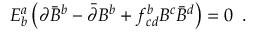Convert formula to latex. <formula><loc_0><loc_0><loc_500><loc_500>E _ { b } ^ { a } \left ( \partial \bar { B } ^ { b } - \bar { \partial } B ^ { b } + f _ { c d } ^ { b } B ^ { c } \bar { B } ^ { d } \right ) = 0 \, .</formula> 